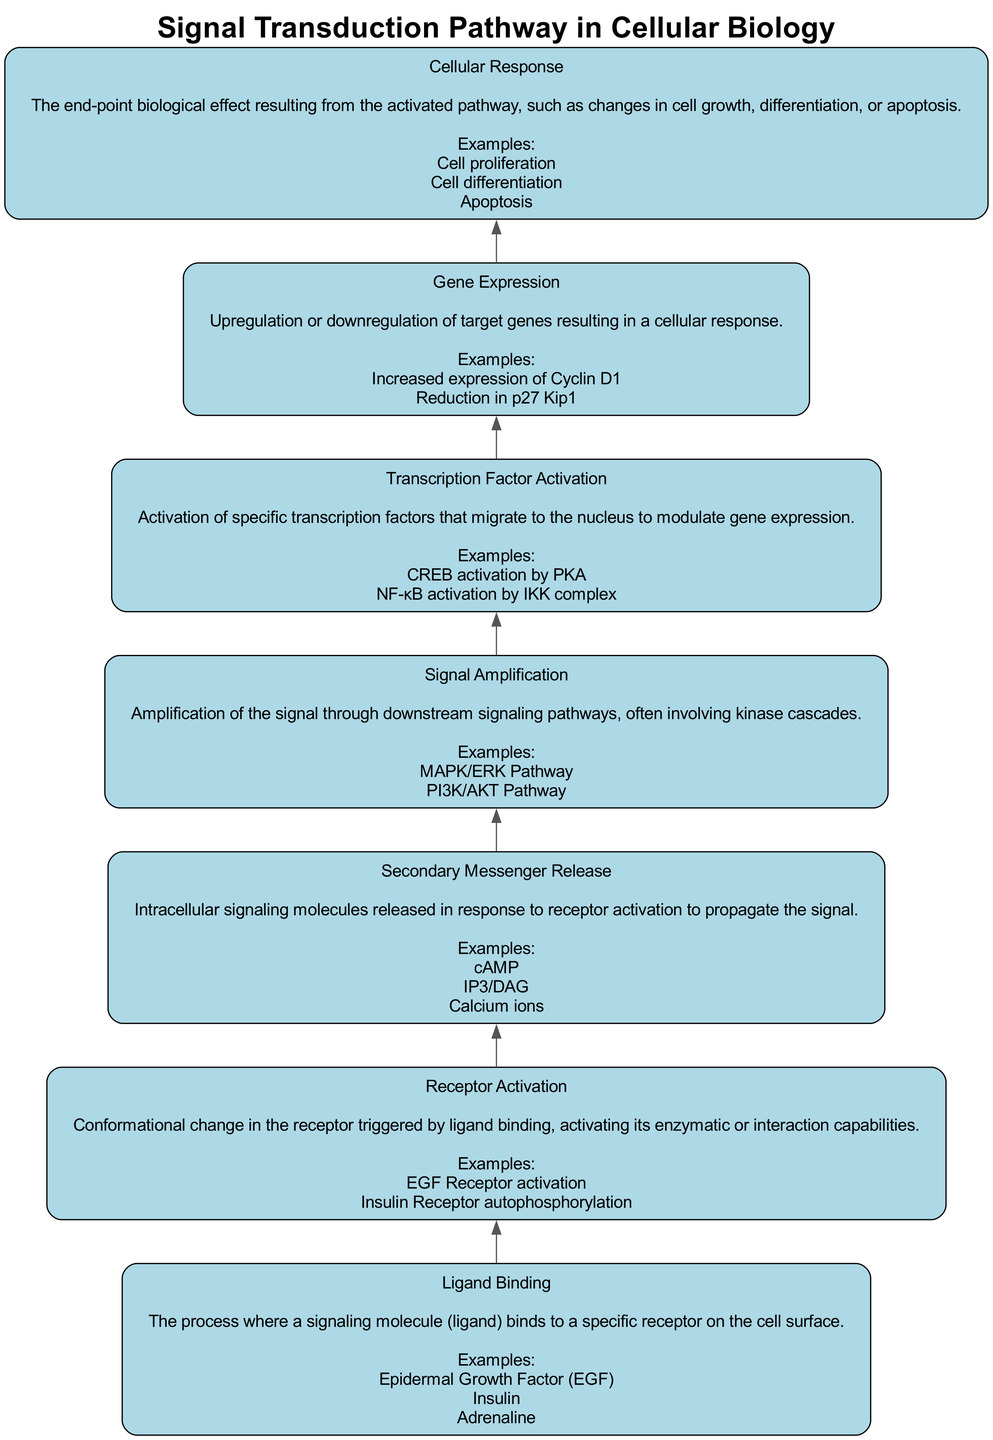What is the first step in the signal transduction pathway? The first step is "Ligand Binding," where a signaling molecule binds to a specific receptor on the cell surface. This is indicated as the bottommost node in the diagram.
Answer: Ligand Binding How many examples are given for "Receptor Activation"? In the node for "Receptor Activation," there are two examples provided: "EGF Receptor activation" and "Insulin Receptor autophosphorylation." Counting these gives a total of two examples.
Answer: 2 What connects "Secondary Messenger Release" to "Signal Amplification"? The connection is indicated by a directed edge (arrow) in the flow chart showing that after "Secondary Messenger Release," the next step in the process is "Signal Amplification." Thus, "Signal Amplification" is downstream of "Secondary Messenger Release."
Answer: An arrow Which step directly precedes "Cellular Response"? The step that directly precedes "Cellular Response" in the flow chart is "Gene Expression." This is the last step before the biological effect is reached.
Answer: Gene Expression What type of molecular event occurs during "Transcription Factor Activation"? The "Transcription Factor Activation" node describes the activation of specific transcription factors that migrate to the nucleus, indicating that this involves a cellular and molecular process related to gene expression.
Answer: Activation of transcription factors Which example was given for "Gene Expression"? The example provided for "Gene Expression" in the diagram is "Increased expression of Cyclin D1." This indicates a specific cellular response resulting from the upregulation or downregulation of genes.
Answer: Increased expression of Cyclin D1 What is the final outcome of the signaling pathway? The final outcome, as indicated in the "Cellular Response" node, includes biological effects such as changes in cell growth, differentiation, or apoptosis.
Answer: Changes in cell growth, differentiation, or apoptosis How many nodes are present in the diagram? The diagram presents a total of seven nodes, as each of the steps in the signaling pathway is represented as a distinct node connecting sequentially.
Answer: 7 Which two nodes represent amplification steps in the pathway? The nodes representing amplification steps are "Secondary Messenger Release" and "Signal Amplification," indicating that signal propagation and amplification occur in these stages.
Answer: Secondary Messenger Release and Signal Amplification 